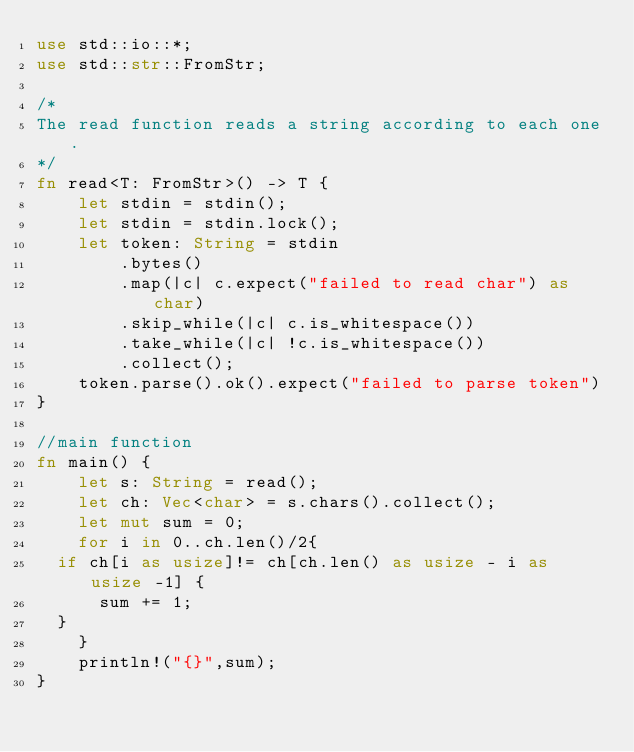<code> <loc_0><loc_0><loc_500><loc_500><_Rust_>use std::io::*;
use std::str::FromStr;
 
/* 
The read function reads a string according to each one. 
*/
fn read<T: FromStr>() -> T {
    let stdin = stdin();
    let stdin = stdin.lock();
    let token: String = stdin
        .bytes()
        .map(|c| c.expect("failed to read char") as char) 
        .skip_while(|c| c.is_whitespace())
        .take_while(|c| !c.is_whitespace())
        .collect();
    token.parse().ok().expect("failed to parse token")
}

//main function
fn main() {
    let s: String = read();
    let ch: Vec<char> = s.chars().collect();
    let mut sum = 0;
    for i in 0..ch.len()/2{
	if ch[i as usize]!= ch[ch.len() as usize - i as usize -1] {
	    sum += 1;
	}
    }
    println!("{}",sum);
}
</code> 